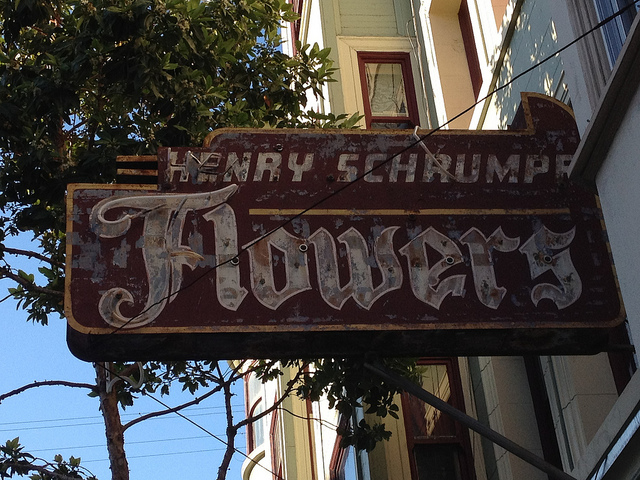Identify and read out the text in this image. HENRY SCHRUMPP HOWERS 